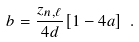Convert formula to latex. <formula><loc_0><loc_0><loc_500><loc_500>b = \frac { z _ { n , \ell } } { 4 d } [ 1 - 4 a ] \ .</formula> 